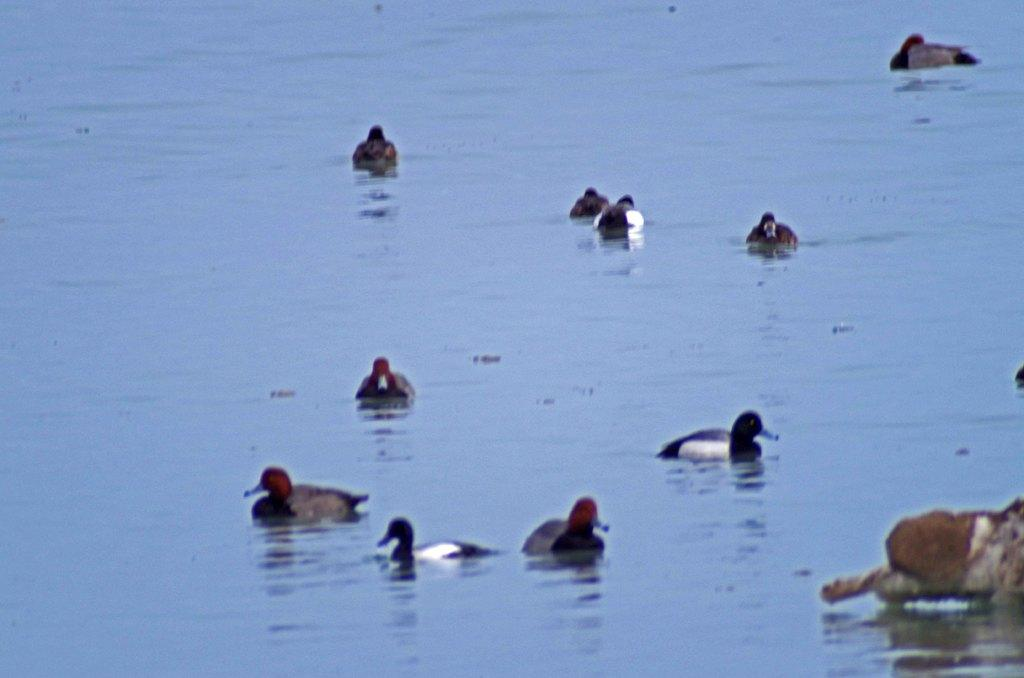What body of water is present in the image? There is a river in the image. What animals can be seen in the river? There are ducks in the river. What can be seen on the right side of the image? There appears to be an animal on the right side. What type of sweater is the drawer wearing in the image? There is no drawer or sweater present in the image. 